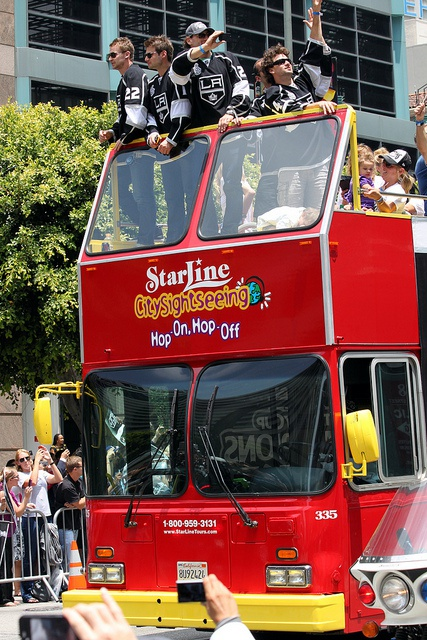Describe the objects in this image and their specific colors. I can see bus in darkgray, black, brown, and red tones, motorcycle in darkgray, lightgray, brown, and black tones, people in darkgray, black, gray, and lightgray tones, people in darkgray, black, gray, white, and brown tones, and people in darkgray, black, gray, and white tones in this image. 